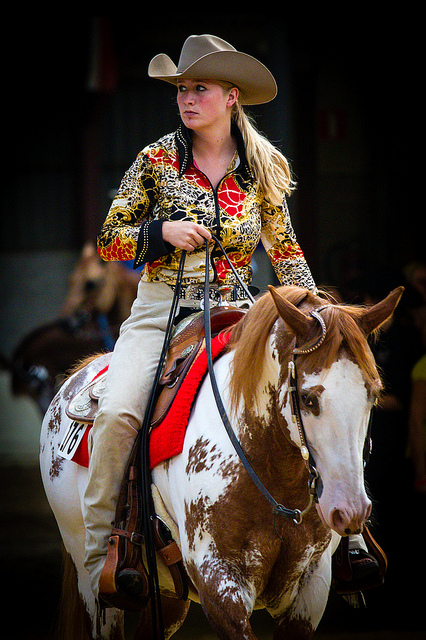What can you infer about the horse's breed from this image? The horse in the image has a distinctive coat pattern with large brown and white spots, characteristic of a Pinto horse. Pintos are known for their coloration but are not a specific breed; rather, they can belong to various breeds that carry the gene for this coat pattern. 